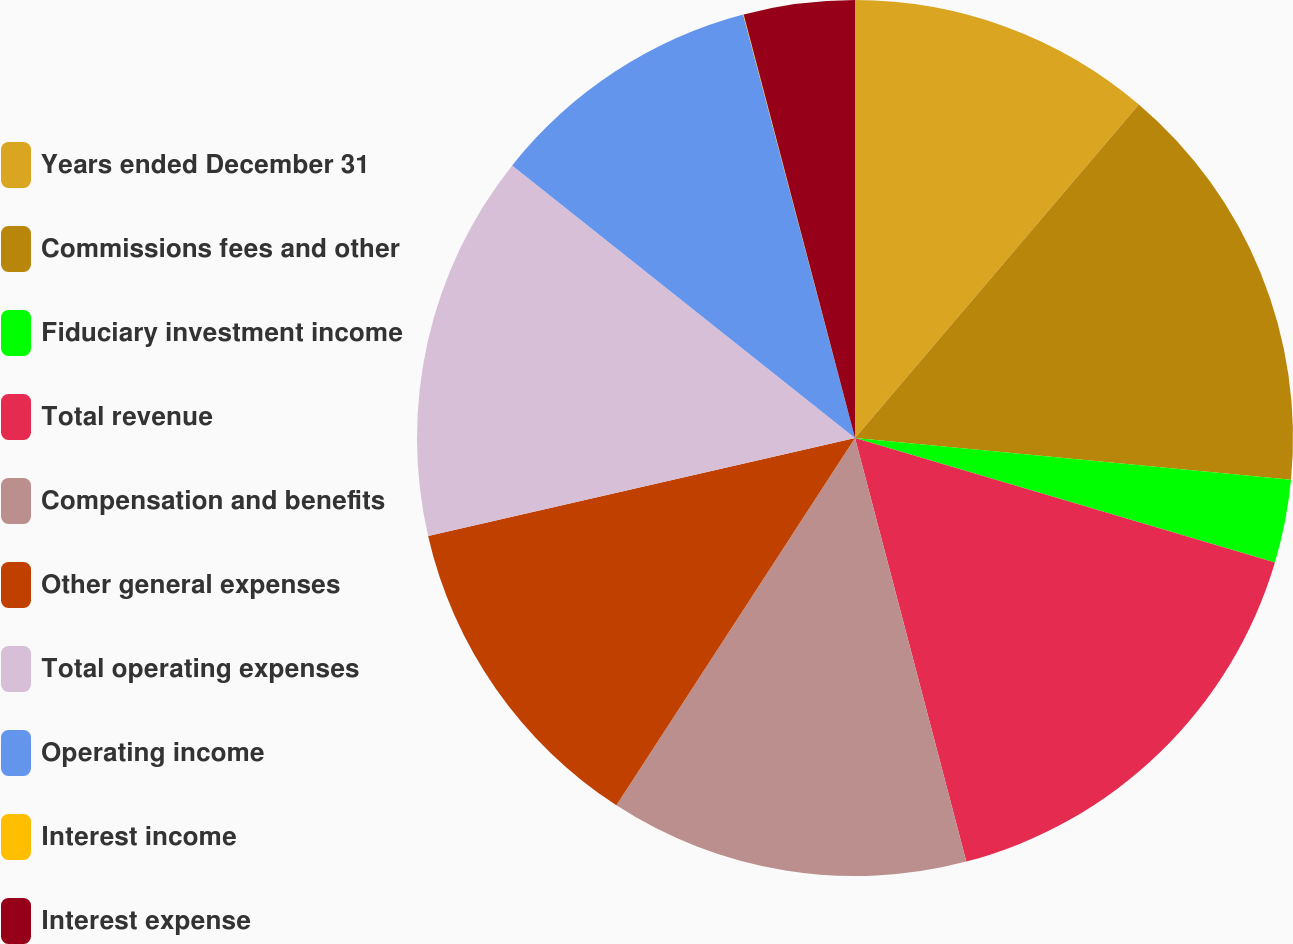<chart> <loc_0><loc_0><loc_500><loc_500><pie_chart><fcel>Years ended December 31<fcel>Commissions fees and other<fcel>Fiduciary investment income<fcel>Total revenue<fcel>Compensation and benefits<fcel>Other general expenses<fcel>Total operating expenses<fcel>Operating income<fcel>Interest income<fcel>Interest expense<nl><fcel>11.22%<fcel>15.3%<fcel>3.07%<fcel>16.32%<fcel>13.26%<fcel>12.24%<fcel>14.28%<fcel>10.2%<fcel>0.02%<fcel>4.09%<nl></chart> 